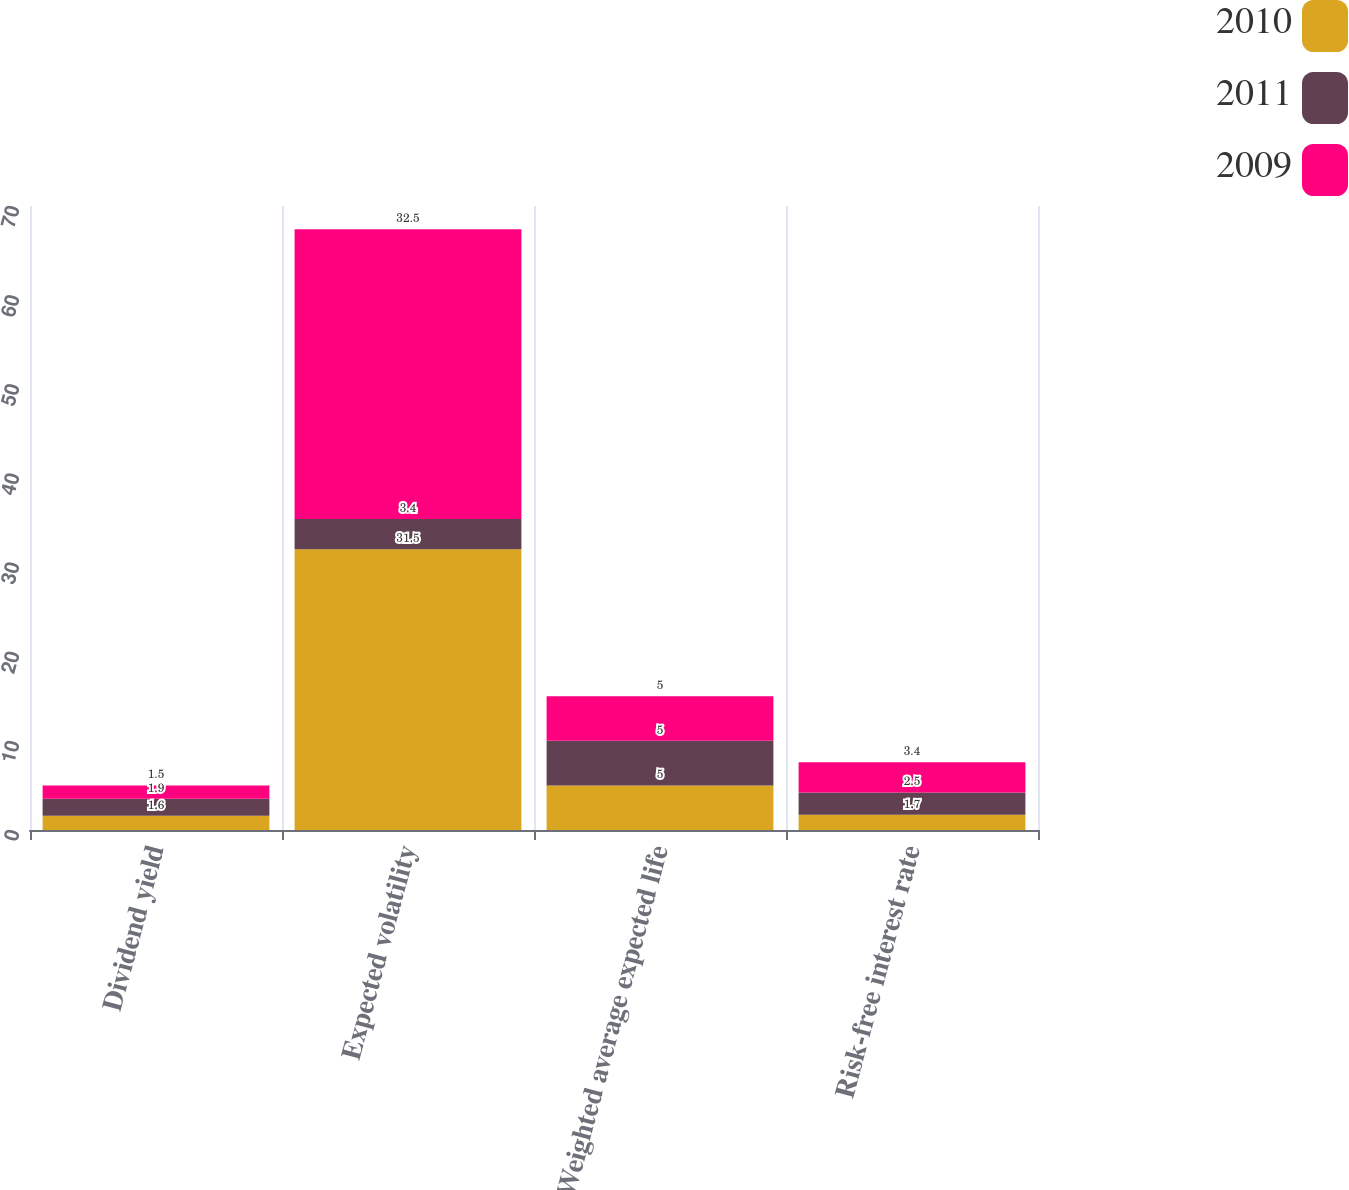Convert chart to OTSL. <chart><loc_0><loc_0><loc_500><loc_500><stacked_bar_chart><ecel><fcel>Dividend yield<fcel>Expected volatility<fcel>Weighted average expected life<fcel>Risk-free interest rate<nl><fcel>2010<fcel>1.6<fcel>31.5<fcel>5<fcel>1.7<nl><fcel>2011<fcel>1.9<fcel>3.4<fcel>5<fcel>2.5<nl><fcel>2009<fcel>1.5<fcel>32.5<fcel>5<fcel>3.4<nl></chart> 